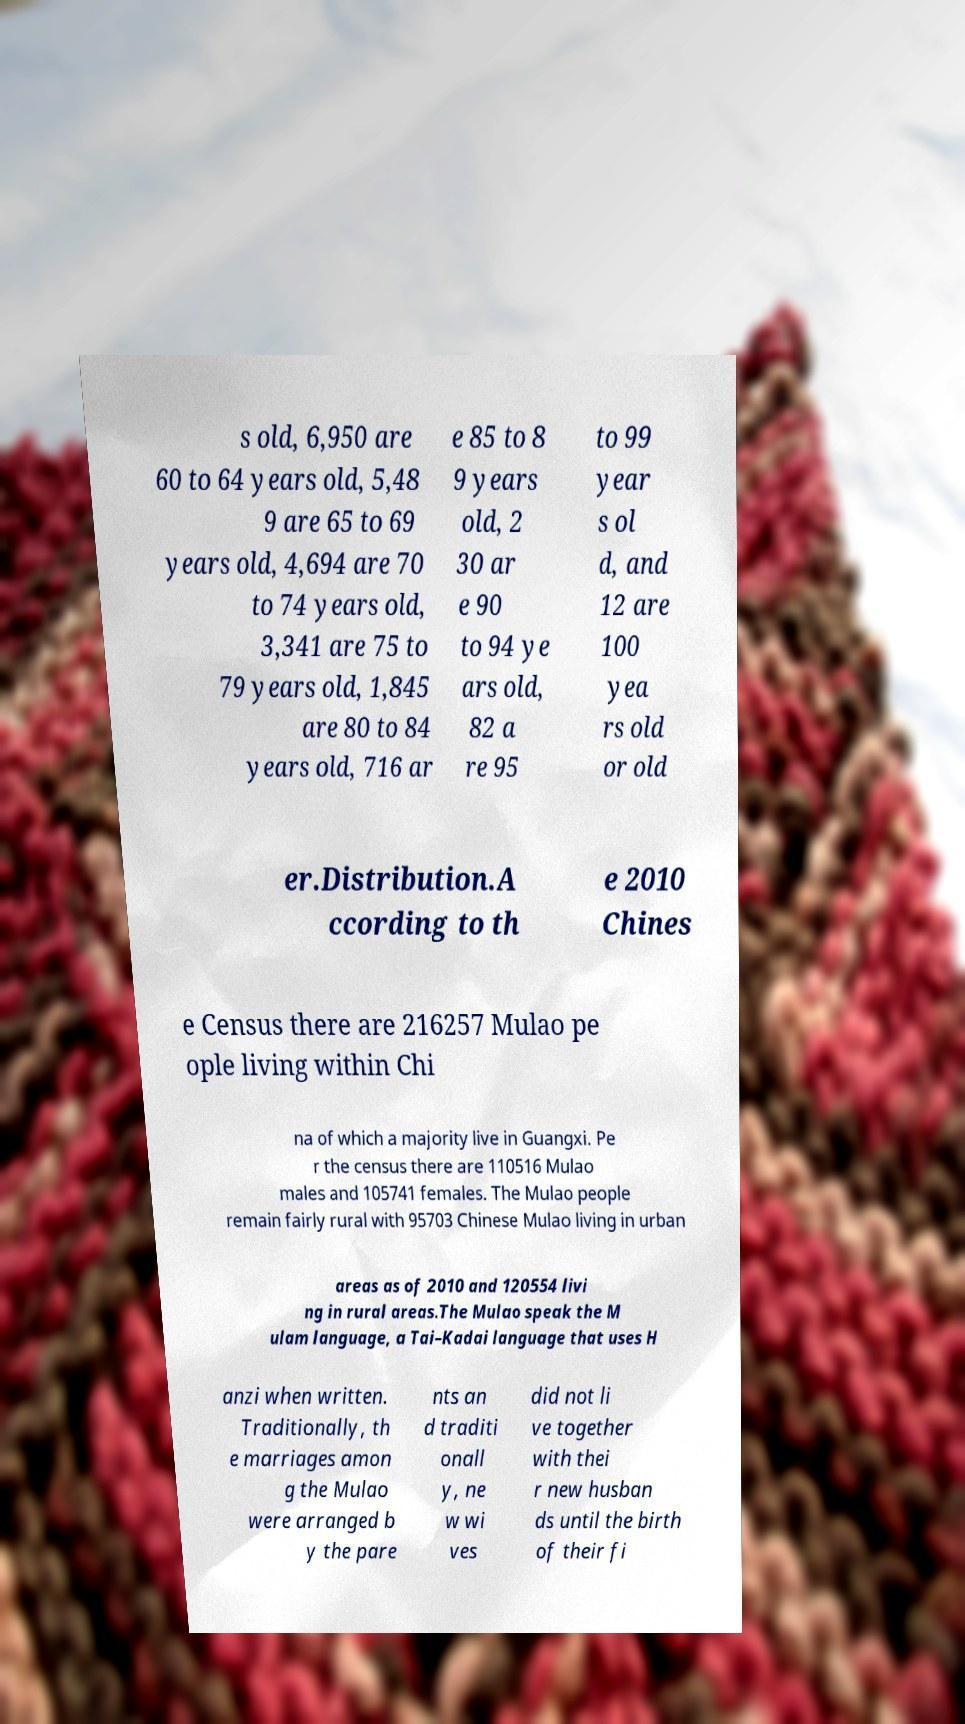Please read and relay the text visible in this image. What does it say? s old, 6,950 are 60 to 64 years old, 5,48 9 are 65 to 69 years old, 4,694 are 70 to 74 years old, 3,341 are 75 to 79 years old, 1,845 are 80 to 84 years old, 716 ar e 85 to 8 9 years old, 2 30 ar e 90 to 94 ye ars old, 82 a re 95 to 99 year s ol d, and 12 are 100 yea rs old or old er.Distribution.A ccording to th e 2010 Chines e Census there are 216257 Mulao pe ople living within Chi na of which a majority live in Guangxi. Pe r the census there are 110516 Mulao males and 105741 females. The Mulao people remain fairly rural with 95703 Chinese Mulao living in urban areas as of 2010 and 120554 livi ng in rural areas.The Mulao speak the M ulam language, a Tai–Kadai language that uses H anzi when written. Traditionally, th e marriages amon g the Mulao were arranged b y the pare nts an d traditi onall y, ne w wi ves did not li ve together with thei r new husban ds until the birth of their fi 